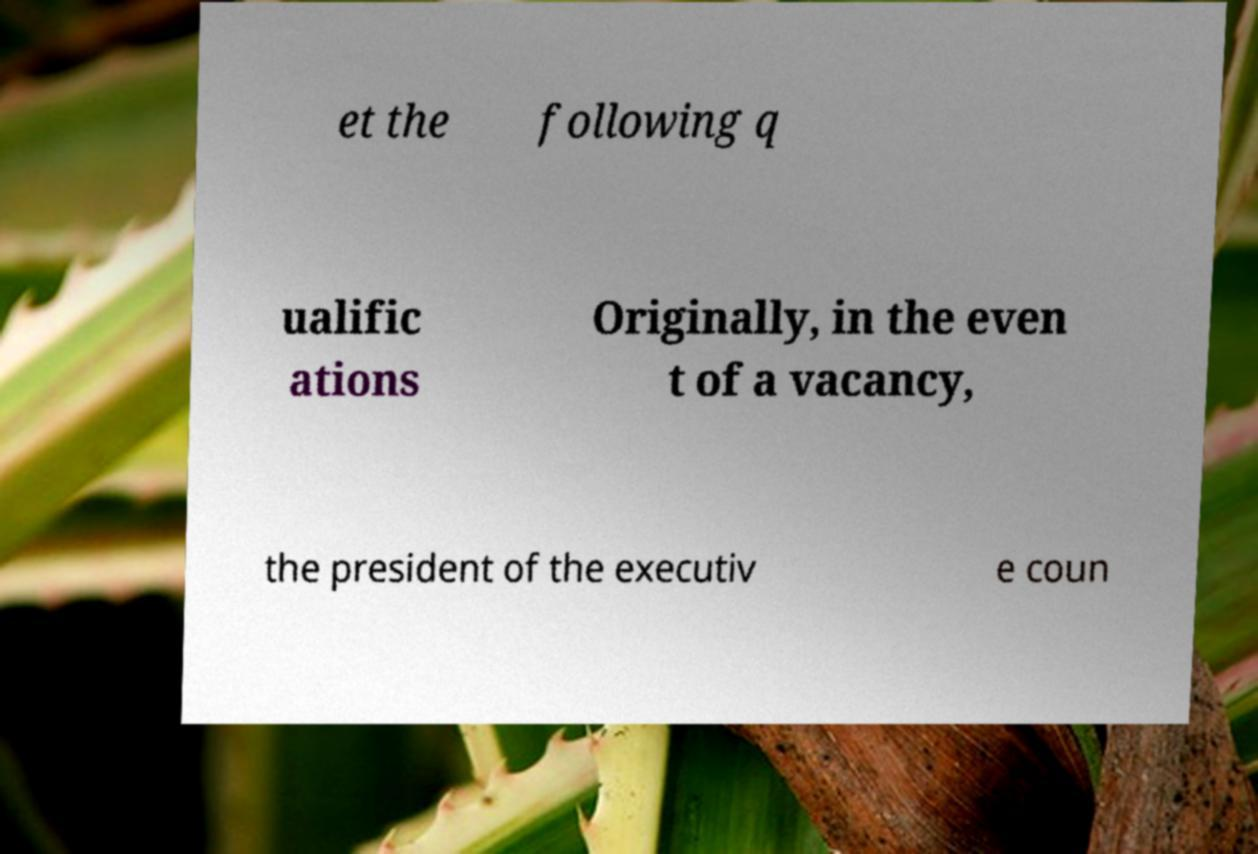Please read and relay the text visible in this image. What does it say? et the following q ualific ations Originally, in the even t of a vacancy, the president of the executiv e coun 